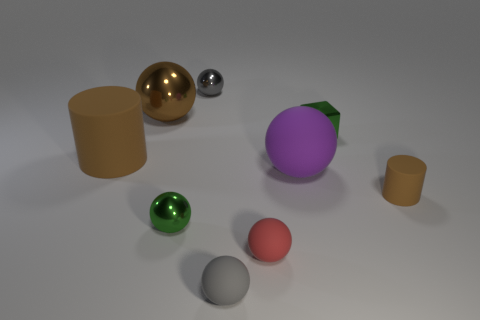Subtract all purple cylinders. How many gray spheres are left? 2 Subtract all purple spheres. How many spheres are left? 5 Subtract 3 spheres. How many spheres are left? 3 Subtract all gray spheres. How many spheres are left? 4 Subtract 1 red balls. How many objects are left? 8 Subtract all spheres. How many objects are left? 3 Subtract all purple spheres. Subtract all yellow cylinders. How many spheres are left? 5 Subtract all purple rubber spheres. Subtract all large rubber cylinders. How many objects are left? 7 Add 3 tiny green things. How many tiny green things are left? 5 Add 4 big metal spheres. How many big metal spheres exist? 5 